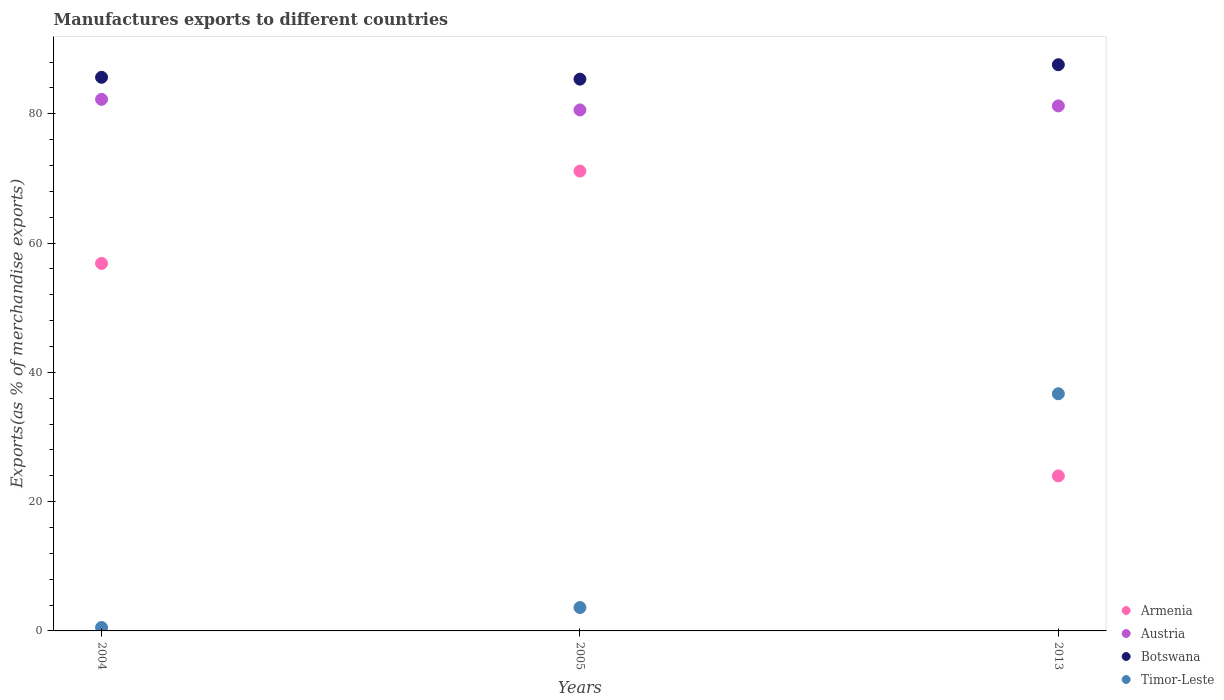Is the number of dotlines equal to the number of legend labels?
Offer a very short reply. Yes. What is the percentage of exports to different countries in Austria in 2005?
Your response must be concise. 80.59. Across all years, what is the maximum percentage of exports to different countries in Armenia?
Provide a succinct answer. 71.13. Across all years, what is the minimum percentage of exports to different countries in Armenia?
Your response must be concise. 23.98. In which year was the percentage of exports to different countries in Austria maximum?
Give a very brief answer. 2004. In which year was the percentage of exports to different countries in Austria minimum?
Provide a succinct answer. 2005. What is the total percentage of exports to different countries in Austria in the graph?
Your response must be concise. 244.02. What is the difference between the percentage of exports to different countries in Armenia in 2004 and that in 2005?
Provide a succinct answer. -14.29. What is the difference between the percentage of exports to different countries in Austria in 2013 and the percentage of exports to different countries in Botswana in 2005?
Your answer should be very brief. -4.14. What is the average percentage of exports to different countries in Austria per year?
Offer a very short reply. 81.34. In the year 2004, what is the difference between the percentage of exports to different countries in Timor-Leste and percentage of exports to different countries in Botswana?
Give a very brief answer. -85.1. In how many years, is the percentage of exports to different countries in Botswana greater than 24 %?
Your response must be concise. 3. What is the ratio of the percentage of exports to different countries in Timor-Leste in 2005 to that in 2013?
Your answer should be compact. 0.1. Is the percentage of exports to different countries in Botswana in 2005 less than that in 2013?
Offer a very short reply. Yes. What is the difference between the highest and the second highest percentage of exports to different countries in Armenia?
Offer a terse response. 14.29. What is the difference between the highest and the lowest percentage of exports to different countries in Austria?
Your answer should be very brief. 1.64. In how many years, is the percentage of exports to different countries in Timor-Leste greater than the average percentage of exports to different countries in Timor-Leste taken over all years?
Offer a terse response. 1. Is the sum of the percentage of exports to different countries in Armenia in 2004 and 2013 greater than the maximum percentage of exports to different countries in Austria across all years?
Make the answer very short. No. How many years are there in the graph?
Your answer should be very brief. 3. Where does the legend appear in the graph?
Offer a very short reply. Bottom right. How many legend labels are there?
Your answer should be very brief. 4. How are the legend labels stacked?
Provide a short and direct response. Vertical. What is the title of the graph?
Provide a short and direct response. Manufactures exports to different countries. Does "Morocco" appear as one of the legend labels in the graph?
Provide a succinct answer. No. What is the label or title of the X-axis?
Provide a succinct answer. Years. What is the label or title of the Y-axis?
Provide a succinct answer. Exports(as % of merchandise exports). What is the Exports(as % of merchandise exports) of Armenia in 2004?
Give a very brief answer. 56.85. What is the Exports(as % of merchandise exports) of Austria in 2004?
Your answer should be compact. 82.23. What is the Exports(as % of merchandise exports) of Botswana in 2004?
Offer a very short reply. 85.63. What is the Exports(as % of merchandise exports) of Timor-Leste in 2004?
Make the answer very short. 0.53. What is the Exports(as % of merchandise exports) in Armenia in 2005?
Your answer should be very brief. 71.13. What is the Exports(as % of merchandise exports) in Austria in 2005?
Offer a terse response. 80.59. What is the Exports(as % of merchandise exports) of Botswana in 2005?
Your answer should be compact. 85.35. What is the Exports(as % of merchandise exports) of Timor-Leste in 2005?
Your answer should be very brief. 3.62. What is the Exports(as % of merchandise exports) in Armenia in 2013?
Ensure brevity in your answer.  23.98. What is the Exports(as % of merchandise exports) of Austria in 2013?
Your answer should be very brief. 81.21. What is the Exports(as % of merchandise exports) in Botswana in 2013?
Your answer should be very brief. 87.58. What is the Exports(as % of merchandise exports) in Timor-Leste in 2013?
Make the answer very short. 36.69. Across all years, what is the maximum Exports(as % of merchandise exports) in Armenia?
Make the answer very short. 71.13. Across all years, what is the maximum Exports(as % of merchandise exports) in Austria?
Your response must be concise. 82.23. Across all years, what is the maximum Exports(as % of merchandise exports) in Botswana?
Offer a very short reply. 87.58. Across all years, what is the maximum Exports(as % of merchandise exports) in Timor-Leste?
Ensure brevity in your answer.  36.69. Across all years, what is the minimum Exports(as % of merchandise exports) of Armenia?
Your answer should be very brief. 23.98. Across all years, what is the minimum Exports(as % of merchandise exports) in Austria?
Your answer should be very brief. 80.59. Across all years, what is the minimum Exports(as % of merchandise exports) of Botswana?
Provide a succinct answer. 85.35. Across all years, what is the minimum Exports(as % of merchandise exports) of Timor-Leste?
Your answer should be very brief. 0.53. What is the total Exports(as % of merchandise exports) in Armenia in the graph?
Offer a terse response. 151.96. What is the total Exports(as % of merchandise exports) of Austria in the graph?
Make the answer very short. 244.02. What is the total Exports(as % of merchandise exports) of Botswana in the graph?
Provide a succinct answer. 258.56. What is the total Exports(as % of merchandise exports) in Timor-Leste in the graph?
Your answer should be very brief. 40.83. What is the difference between the Exports(as % of merchandise exports) of Armenia in 2004 and that in 2005?
Give a very brief answer. -14.29. What is the difference between the Exports(as % of merchandise exports) in Austria in 2004 and that in 2005?
Keep it short and to the point. 1.64. What is the difference between the Exports(as % of merchandise exports) of Botswana in 2004 and that in 2005?
Offer a very short reply. 0.28. What is the difference between the Exports(as % of merchandise exports) in Timor-Leste in 2004 and that in 2005?
Give a very brief answer. -3.09. What is the difference between the Exports(as % of merchandise exports) in Armenia in 2004 and that in 2013?
Your response must be concise. 32.87. What is the difference between the Exports(as % of merchandise exports) in Austria in 2004 and that in 2013?
Provide a short and direct response. 1.02. What is the difference between the Exports(as % of merchandise exports) in Botswana in 2004 and that in 2013?
Ensure brevity in your answer.  -1.95. What is the difference between the Exports(as % of merchandise exports) of Timor-Leste in 2004 and that in 2013?
Ensure brevity in your answer.  -36.16. What is the difference between the Exports(as % of merchandise exports) of Armenia in 2005 and that in 2013?
Give a very brief answer. 47.16. What is the difference between the Exports(as % of merchandise exports) of Austria in 2005 and that in 2013?
Keep it short and to the point. -0.62. What is the difference between the Exports(as % of merchandise exports) in Botswana in 2005 and that in 2013?
Provide a short and direct response. -2.23. What is the difference between the Exports(as % of merchandise exports) of Timor-Leste in 2005 and that in 2013?
Your answer should be very brief. -33.07. What is the difference between the Exports(as % of merchandise exports) in Armenia in 2004 and the Exports(as % of merchandise exports) in Austria in 2005?
Offer a very short reply. -23.74. What is the difference between the Exports(as % of merchandise exports) of Armenia in 2004 and the Exports(as % of merchandise exports) of Botswana in 2005?
Provide a succinct answer. -28.5. What is the difference between the Exports(as % of merchandise exports) of Armenia in 2004 and the Exports(as % of merchandise exports) of Timor-Leste in 2005?
Offer a very short reply. 53.23. What is the difference between the Exports(as % of merchandise exports) in Austria in 2004 and the Exports(as % of merchandise exports) in Botswana in 2005?
Keep it short and to the point. -3.12. What is the difference between the Exports(as % of merchandise exports) of Austria in 2004 and the Exports(as % of merchandise exports) of Timor-Leste in 2005?
Offer a very short reply. 78.61. What is the difference between the Exports(as % of merchandise exports) in Botswana in 2004 and the Exports(as % of merchandise exports) in Timor-Leste in 2005?
Provide a short and direct response. 82.01. What is the difference between the Exports(as % of merchandise exports) in Armenia in 2004 and the Exports(as % of merchandise exports) in Austria in 2013?
Provide a succinct answer. -24.36. What is the difference between the Exports(as % of merchandise exports) of Armenia in 2004 and the Exports(as % of merchandise exports) of Botswana in 2013?
Keep it short and to the point. -30.73. What is the difference between the Exports(as % of merchandise exports) of Armenia in 2004 and the Exports(as % of merchandise exports) of Timor-Leste in 2013?
Provide a succinct answer. 20.16. What is the difference between the Exports(as % of merchandise exports) of Austria in 2004 and the Exports(as % of merchandise exports) of Botswana in 2013?
Offer a terse response. -5.35. What is the difference between the Exports(as % of merchandise exports) of Austria in 2004 and the Exports(as % of merchandise exports) of Timor-Leste in 2013?
Provide a succinct answer. 45.54. What is the difference between the Exports(as % of merchandise exports) in Botswana in 2004 and the Exports(as % of merchandise exports) in Timor-Leste in 2013?
Offer a very short reply. 48.94. What is the difference between the Exports(as % of merchandise exports) of Armenia in 2005 and the Exports(as % of merchandise exports) of Austria in 2013?
Provide a succinct answer. -10.08. What is the difference between the Exports(as % of merchandise exports) in Armenia in 2005 and the Exports(as % of merchandise exports) in Botswana in 2013?
Keep it short and to the point. -16.45. What is the difference between the Exports(as % of merchandise exports) in Armenia in 2005 and the Exports(as % of merchandise exports) in Timor-Leste in 2013?
Make the answer very short. 34.45. What is the difference between the Exports(as % of merchandise exports) in Austria in 2005 and the Exports(as % of merchandise exports) in Botswana in 2013?
Offer a terse response. -6.99. What is the difference between the Exports(as % of merchandise exports) of Austria in 2005 and the Exports(as % of merchandise exports) of Timor-Leste in 2013?
Offer a terse response. 43.9. What is the difference between the Exports(as % of merchandise exports) of Botswana in 2005 and the Exports(as % of merchandise exports) of Timor-Leste in 2013?
Your response must be concise. 48.66. What is the average Exports(as % of merchandise exports) of Armenia per year?
Provide a succinct answer. 50.65. What is the average Exports(as % of merchandise exports) of Austria per year?
Offer a terse response. 81.34. What is the average Exports(as % of merchandise exports) of Botswana per year?
Your answer should be very brief. 86.19. What is the average Exports(as % of merchandise exports) in Timor-Leste per year?
Give a very brief answer. 13.61. In the year 2004, what is the difference between the Exports(as % of merchandise exports) of Armenia and Exports(as % of merchandise exports) of Austria?
Provide a short and direct response. -25.38. In the year 2004, what is the difference between the Exports(as % of merchandise exports) in Armenia and Exports(as % of merchandise exports) in Botswana?
Provide a succinct answer. -28.78. In the year 2004, what is the difference between the Exports(as % of merchandise exports) of Armenia and Exports(as % of merchandise exports) of Timor-Leste?
Keep it short and to the point. 56.31. In the year 2004, what is the difference between the Exports(as % of merchandise exports) of Austria and Exports(as % of merchandise exports) of Botswana?
Offer a very short reply. -3.4. In the year 2004, what is the difference between the Exports(as % of merchandise exports) of Austria and Exports(as % of merchandise exports) of Timor-Leste?
Offer a terse response. 81.7. In the year 2004, what is the difference between the Exports(as % of merchandise exports) in Botswana and Exports(as % of merchandise exports) in Timor-Leste?
Offer a very short reply. 85.1. In the year 2005, what is the difference between the Exports(as % of merchandise exports) in Armenia and Exports(as % of merchandise exports) in Austria?
Offer a terse response. -9.45. In the year 2005, what is the difference between the Exports(as % of merchandise exports) in Armenia and Exports(as % of merchandise exports) in Botswana?
Ensure brevity in your answer.  -14.22. In the year 2005, what is the difference between the Exports(as % of merchandise exports) in Armenia and Exports(as % of merchandise exports) in Timor-Leste?
Give a very brief answer. 67.52. In the year 2005, what is the difference between the Exports(as % of merchandise exports) in Austria and Exports(as % of merchandise exports) in Botswana?
Offer a very short reply. -4.76. In the year 2005, what is the difference between the Exports(as % of merchandise exports) of Austria and Exports(as % of merchandise exports) of Timor-Leste?
Offer a very short reply. 76.97. In the year 2005, what is the difference between the Exports(as % of merchandise exports) in Botswana and Exports(as % of merchandise exports) in Timor-Leste?
Ensure brevity in your answer.  81.73. In the year 2013, what is the difference between the Exports(as % of merchandise exports) of Armenia and Exports(as % of merchandise exports) of Austria?
Provide a succinct answer. -57.23. In the year 2013, what is the difference between the Exports(as % of merchandise exports) in Armenia and Exports(as % of merchandise exports) in Botswana?
Your answer should be compact. -63.6. In the year 2013, what is the difference between the Exports(as % of merchandise exports) of Armenia and Exports(as % of merchandise exports) of Timor-Leste?
Keep it short and to the point. -12.71. In the year 2013, what is the difference between the Exports(as % of merchandise exports) of Austria and Exports(as % of merchandise exports) of Botswana?
Give a very brief answer. -6.37. In the year 2013, what is the difference between the Exports(as % of merchandise exports) in Austria and Exports(as % of merchandise exports) in Timor-Leste?
Offer a very short reply. 44.52. In the year 2013, what is the difference between the Exports(as % of merchandise exports) of Botswana and Exports(as % of merchandise exports) of Timor-Leste?
Ensure brevity in your answer.  50.89. What is the ratio of the Exports(as % of merchandise exports) in Armenia in 2004 to that in 2005?
Make the answer very short. 0.8. What is the ratio of the Exports(as % of merchandise exports) in Austria in 2004 to that in 2005?
Offer a terse response. 1.02. What is the ratio of the Exports(as % of merchandise exports) in Timor-Leste in 2004 to that in 2005?
Your answer should be very brief. 0.15. What is the ratio of the Exports(as % of merchandise exports) in Armenia in 2004 to that in 2013?
Offer a terse response. 2.37. What is the ratio of the Exports(as % of merchandise exports) in Austria in 2004 to that in 2013?
Offer a very short reply. 1.01. What is the ratio of the Exports(as % of merchandise exports) of Botswana in 2004 to that in 2013?
Offer a very short reply. 0.98. What is the ratio of the Exports(as % of merchandise exports) of Timor-Leste in 2004 to that in 2013?
Make the answer very short. 0.01. What is the ratio of the Exports(as % of merchandise exports) of Armenia in 2005 to that in 2013?
Your answer should be compact. 2.97. What is the ratio of the Exports(as % of merchandise exports) of Austria in 2005 to that in 2013?
Your answer should be compact. 0.99. What is the ratio of the Exports(as % of merchandise exports) in Botswana in 2005 to that in 2013?
Give a very brief answer. 0.97. What is the ratio of the Exports(as % of merchandise exports) of Timor-Leste in 2005 to that in 2013?
Your answer should be very brief. 0.1. What is the difference between the highest and the second highest Exports(as % of merchandise exports) in Armenia?
Your response must be concise. 14.29. What is the difference between the highest and the second highest Exports(as % of merchandise exports) of Austria?
Provide a short and direct response. 1.02. What is the difference between the highest and the second highest Exports(as % of merchandise exports) of Botswana?
Provide a short and direct response. 1.95. What is the difference between the highest and the second highest Exports(as % of merchandise exports) in Timor-Leste?
Provide a short and direct response. 33.07. What is the difference between the highest and the lowest Exports(as % of merchandise exports) in Armenia?
Provide a short and direct response. 47.16. What is the difference between the highest and the lowest Exports(as % of merchandise exports) of Austria?
Provide a succinct answer. 1.64. What is the difference between the highest and the lowest Exports(as % of merchandise exports) in Botswana?
Your answer should be compact. 2.23. What is the difference between the highest and the lowest Exports(as % of merchandise exports) in Timor-Leste?
Ensure brevity in your answer.  36.16. 